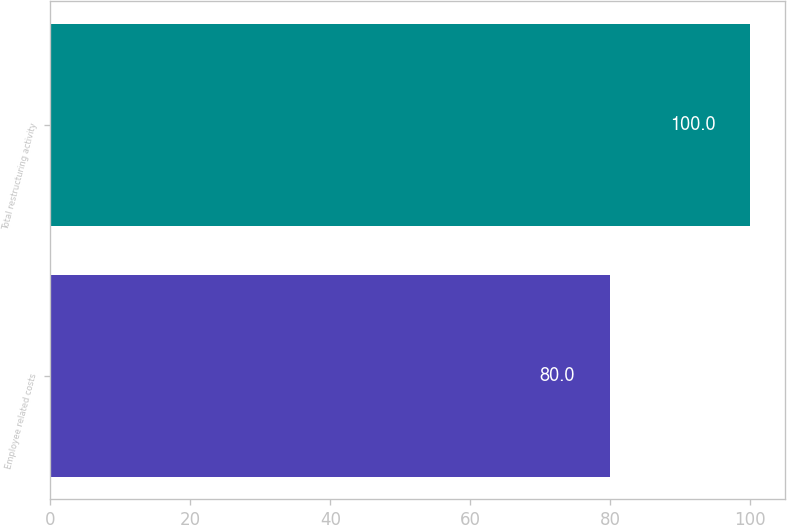Convert chart. <chart><loc_0><loc_0><loc_500><loc_500><bar_chart><fcel>Employee related costs<fcel>Total restructuring activity<nl><fcel>80<fcel>100<nl></chart> 